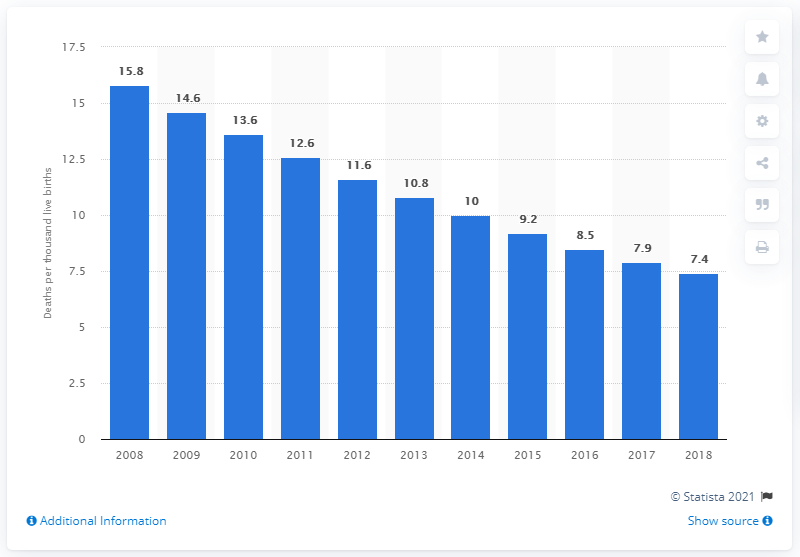Indicate a few pertinent items in this graphic. In 2018, the infant mortality rate in China was 7.4 per 1,000 live births. 